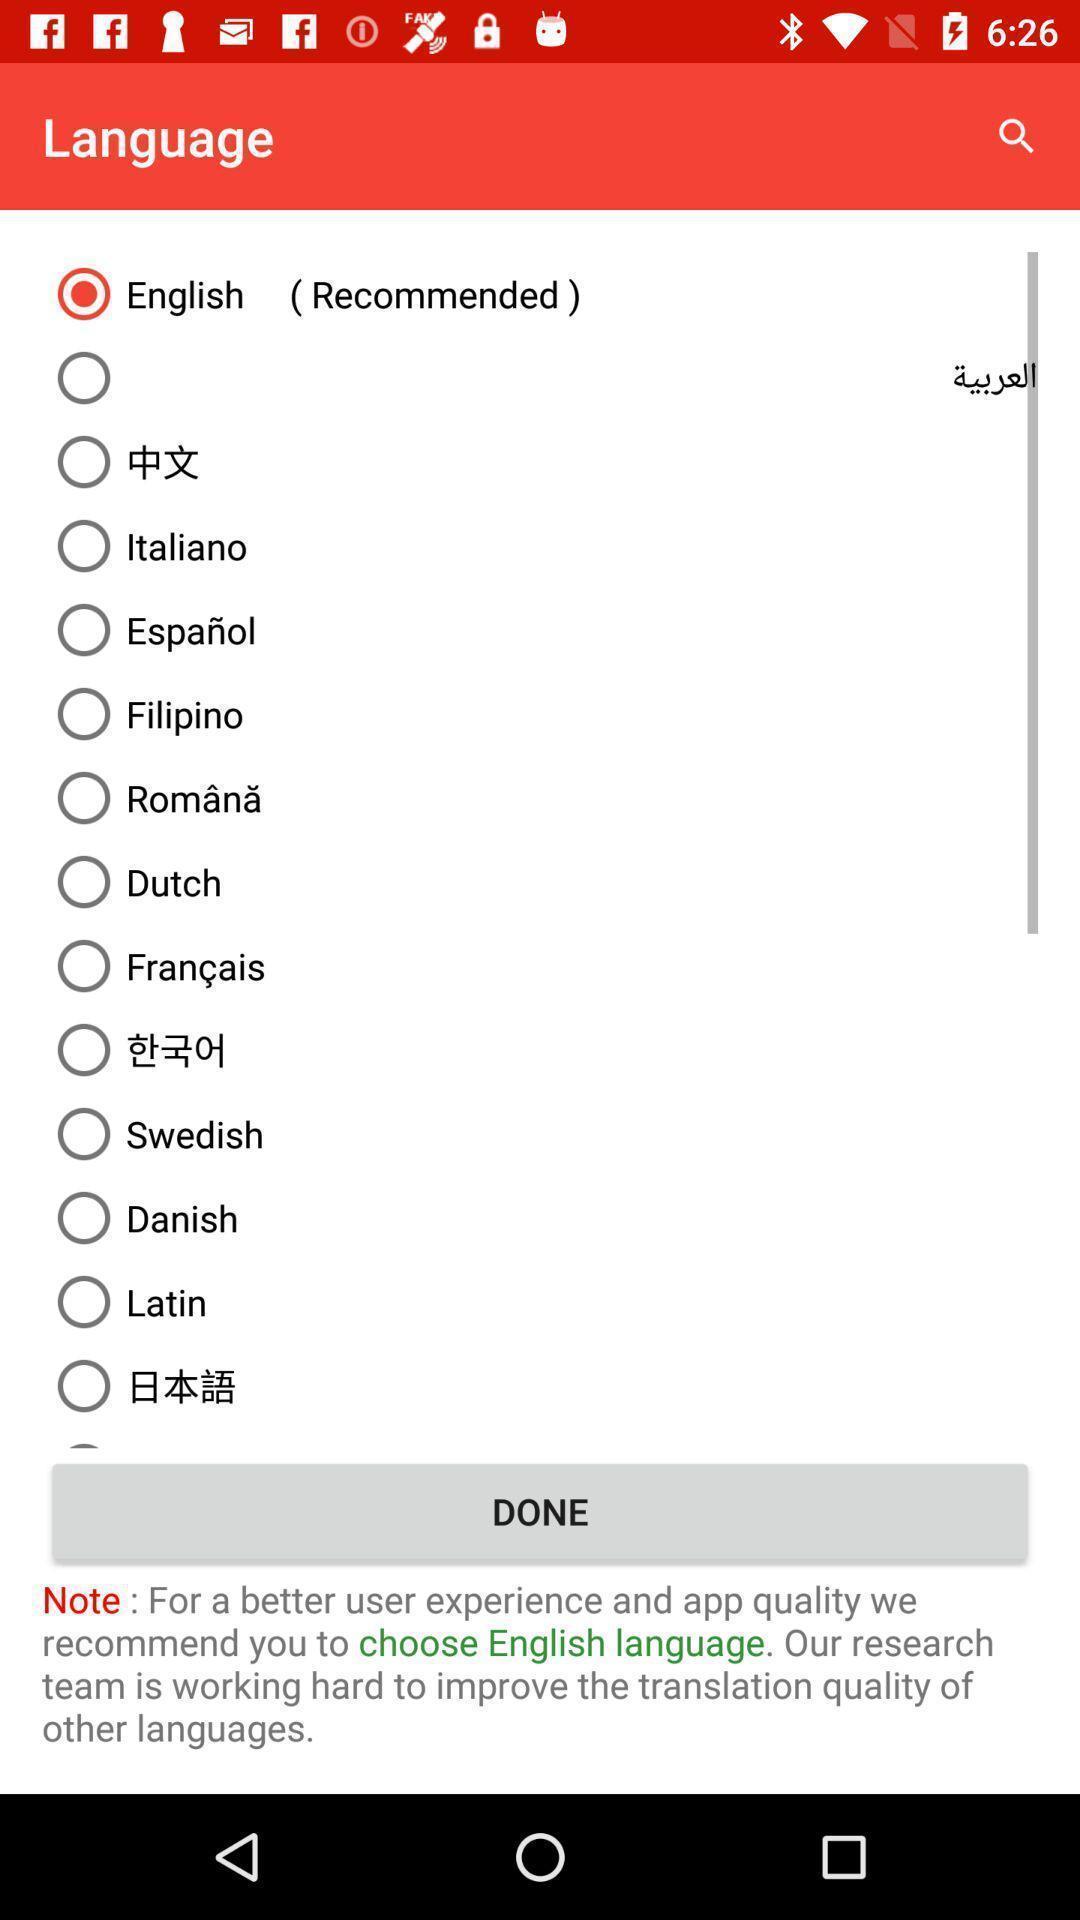Describe the visual elements of this screenshot. Screen showing list of various languages. 